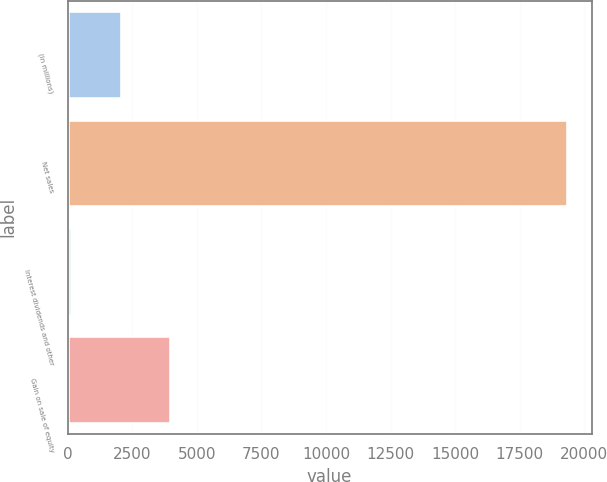Convert chart. <chart><loc_0><loc_0><loc_500><loc_500><bar_chart><fcel>(in millions)<fcel>Net sales<fcel>Interest dividends and other<fcel>Gain on sale of equity<nl><fcel>2048.2<fcel>19312<fcel>130<fcel>3966.4<nl></chart> 